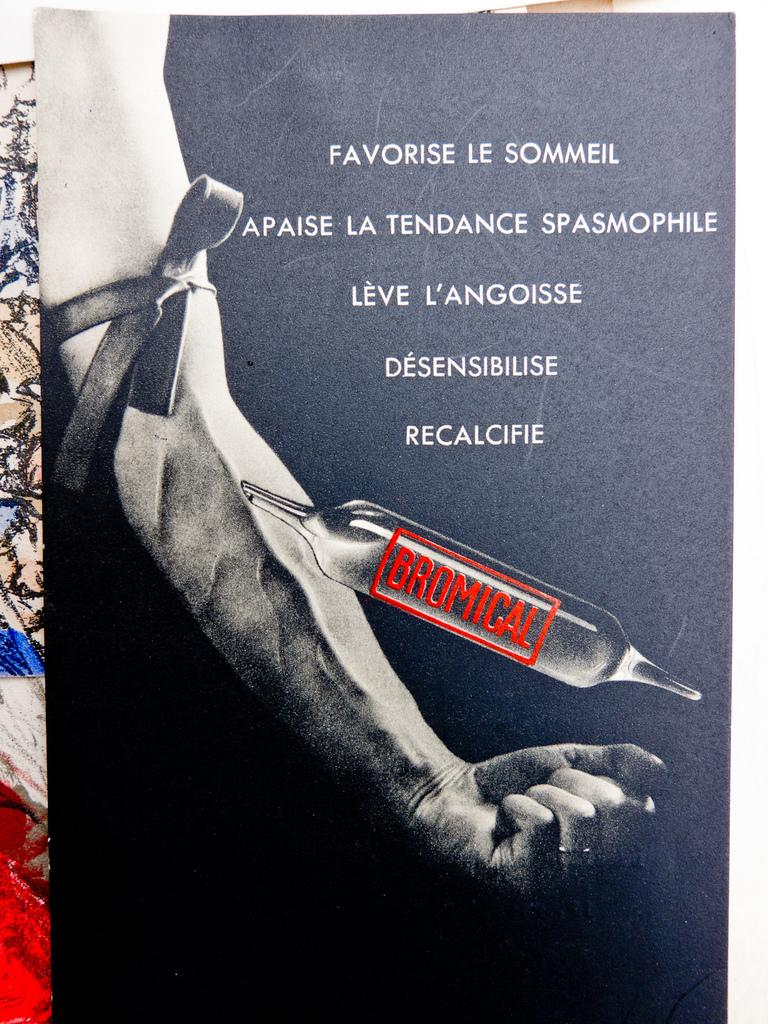What type of image is being described? The image is a poster. What can be seen on the poster besides the letters? There is a person's hand with a ribbon visible on the poster. Can you hear the person laughing in the poster? There is no sound or indication of laughter in the poster; it is a static image. Is there a zoo depicted on the poster? There is no zoo present in the poster; it only features a person's hand with a ribbon and letters. 